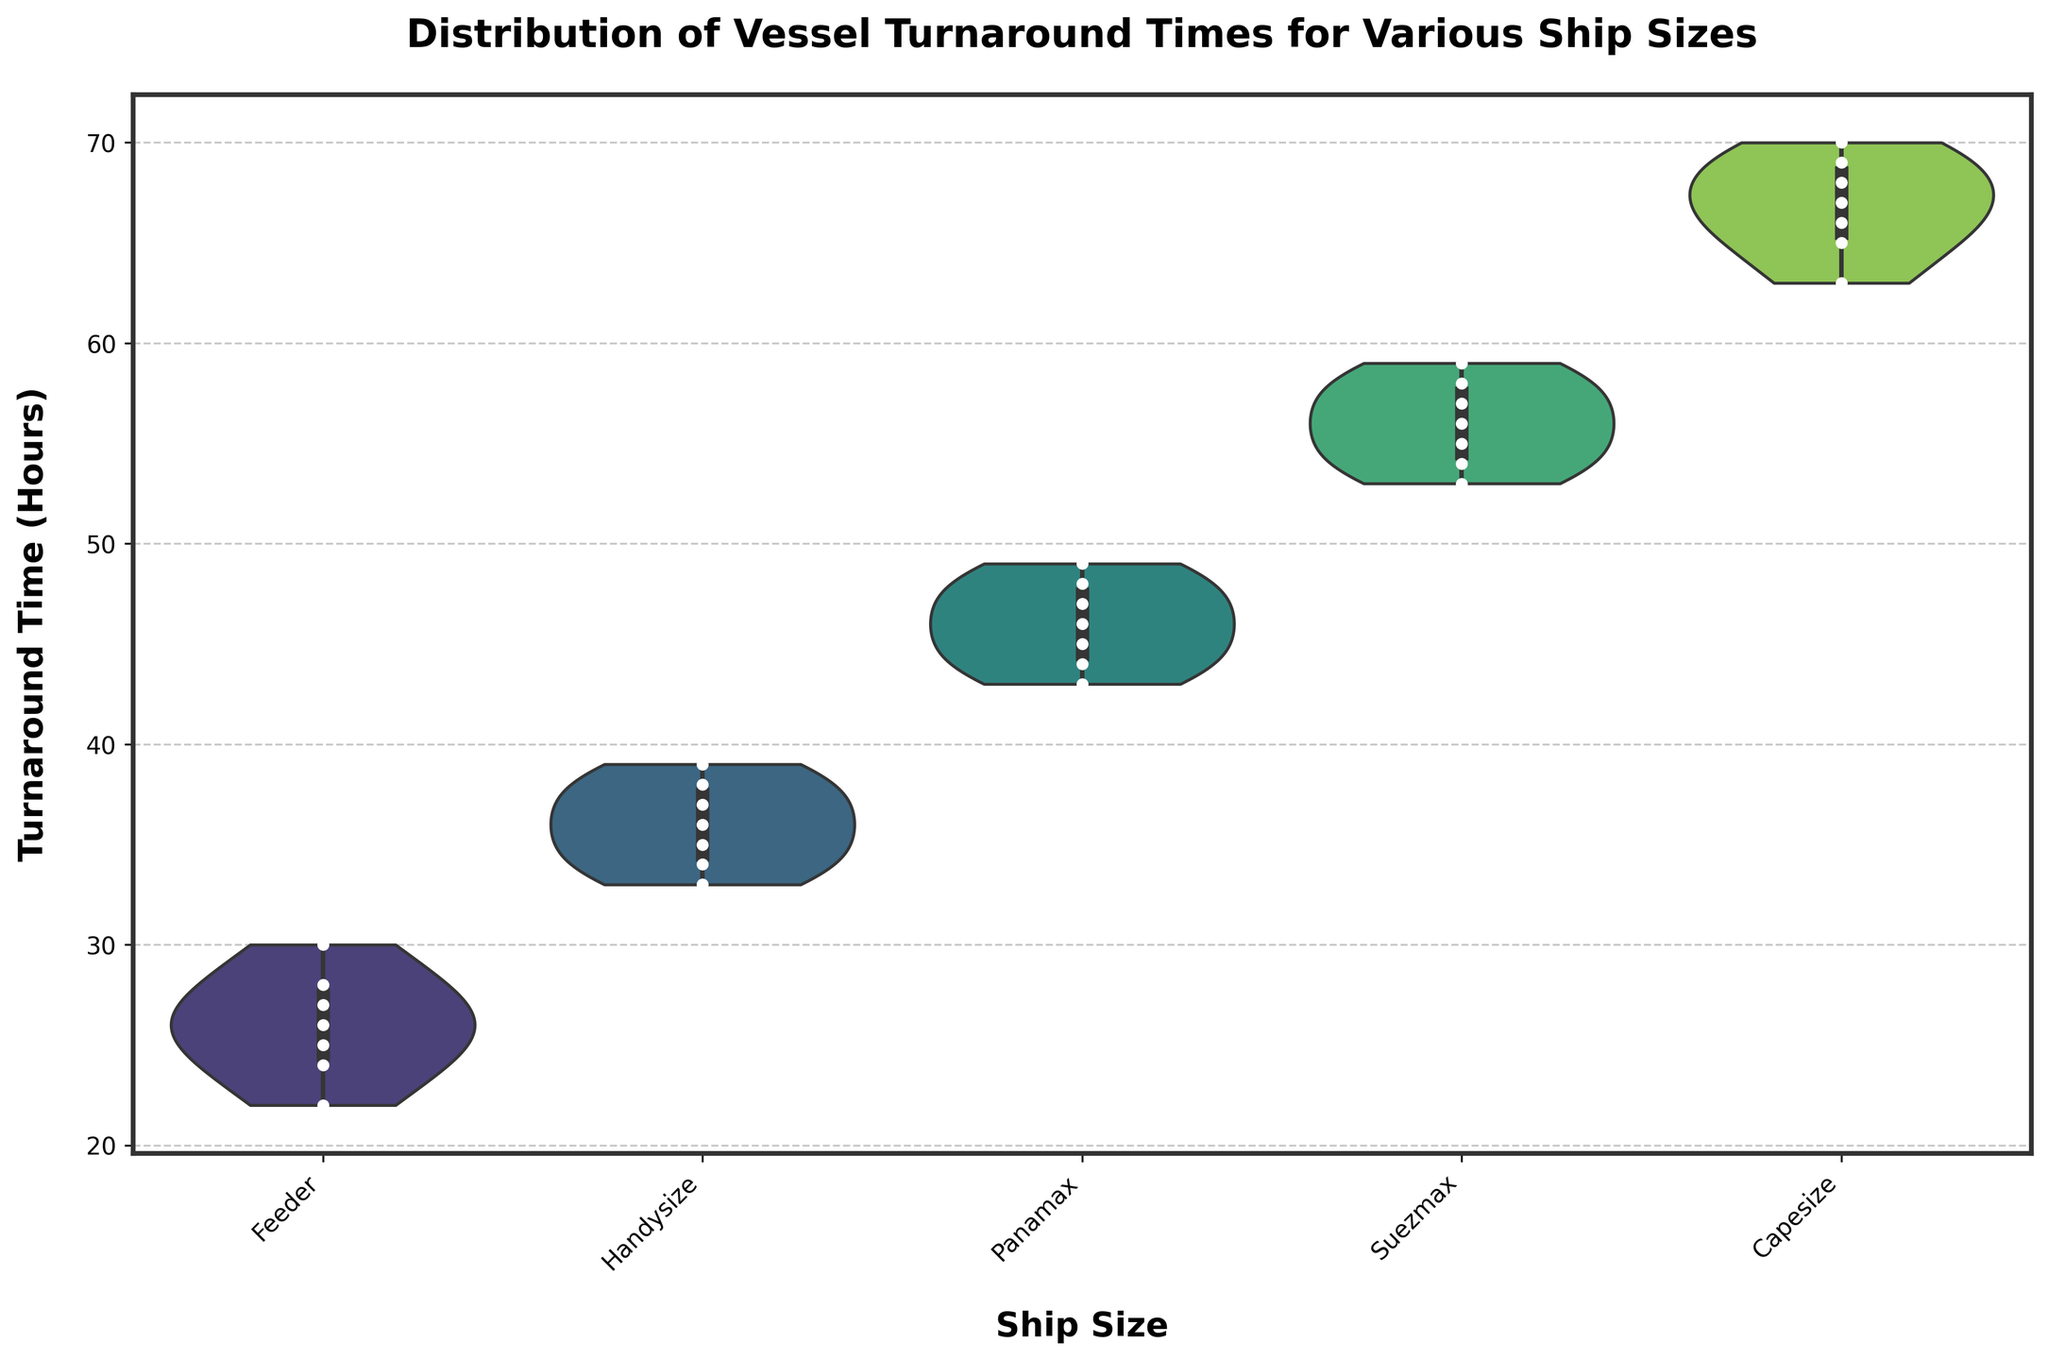What does the title of the chart indicate? The title of the chart indicates the subject of the visualization, which is the "Distribution of Vessel Turnaround Times for Various Ship Sizes". This means the chart displays how the time vessels take to turn around is distributed across different ship sizes.
Answer: Distribution of Vessel Turnaround Times for Various Ship Sizes How are the categories of ship sizes displayed on the x-axis? The x-axis displays the different categories of ship sizes: Feeder, Handysize, Panamax, Suezmax, and Capesize. These labels denote the types of ships being analyzed for their turnaround times.
Answer: Feeder, Handysize, Panamax, Suezmax, Capesize Which ship size has the shortest median turnaround time? By examining the position of the middle horizontal line (the median) within each violin plot, the Feeder ship size has the shortest median turnaround time. The median line in the Feeder category appears lower on the y-axis compared to other ship sizes.
Answer: Feeder What is the range of turnaround times for Panamax ships? The Panamax violin plot’s range extends from the minimum to the maximum values on the y-axis. The bottom part starts at around 43 hours and the top at around 49 hours.
Answer: 43 to 49 hours How do the shapes of the violin plots differ among ship sizes? The shapes of the violin plots indicate the distribution and density of the data points. For example, Feeder and Handysize have more symmetric and narrow distributions, while Capesize shows a more spread and wider distribution. These visual differences reflect the variability in turnaround times.
Answer: Feeder and Handysize are narrow, Capesize is wider Which ship size shows the highest variability in turnaround times? By comparing the width and spread of the violin plots, Capesize shows the highest variability. Its plot is wider and spans a larger range of turnaround times than the other categories, indicating more fluctuations in turnaround times.
Answer: Capesize Which ship size has the most concentrated distribution of turnaround times around the median? Observing the violin plots, Handysize has the most concentrated distribution around the median. This is reflected by the violin plot being taller near the median line with less spread towards the edges.
Answer: Handysize What insights can be drawn from the inner box plots within the violin plots? The inner box plots within each violin indicate the interquartile range (IQR) and median of the turnaround times. For instance, in the Suezmax plot, the box plot spans from the lower quartile around 54 hours to the upper quartile around 58 hours with the median at approximately 56 hours. Such details help in understanding the central tendency and spread.
Answer: Interquartile ranges and medians How are the individual data points represented in the plot? Individual data points are represented by white dots with black edges, distributed along the width of the violin plots. These dots help in identifying exact turnaround times and show data density and distribution directly.
Answer: White dots with black edges Which ship size has the highest median within the Suezmax category? The contour of the Suezmax's violin plot shows that the highest median around 56 hours. Comparing medians within the individual violin plots, the Suezmax's median stands taller than those in Feeder, Handysize, and Panamax categories.
Answer: Suezmax 